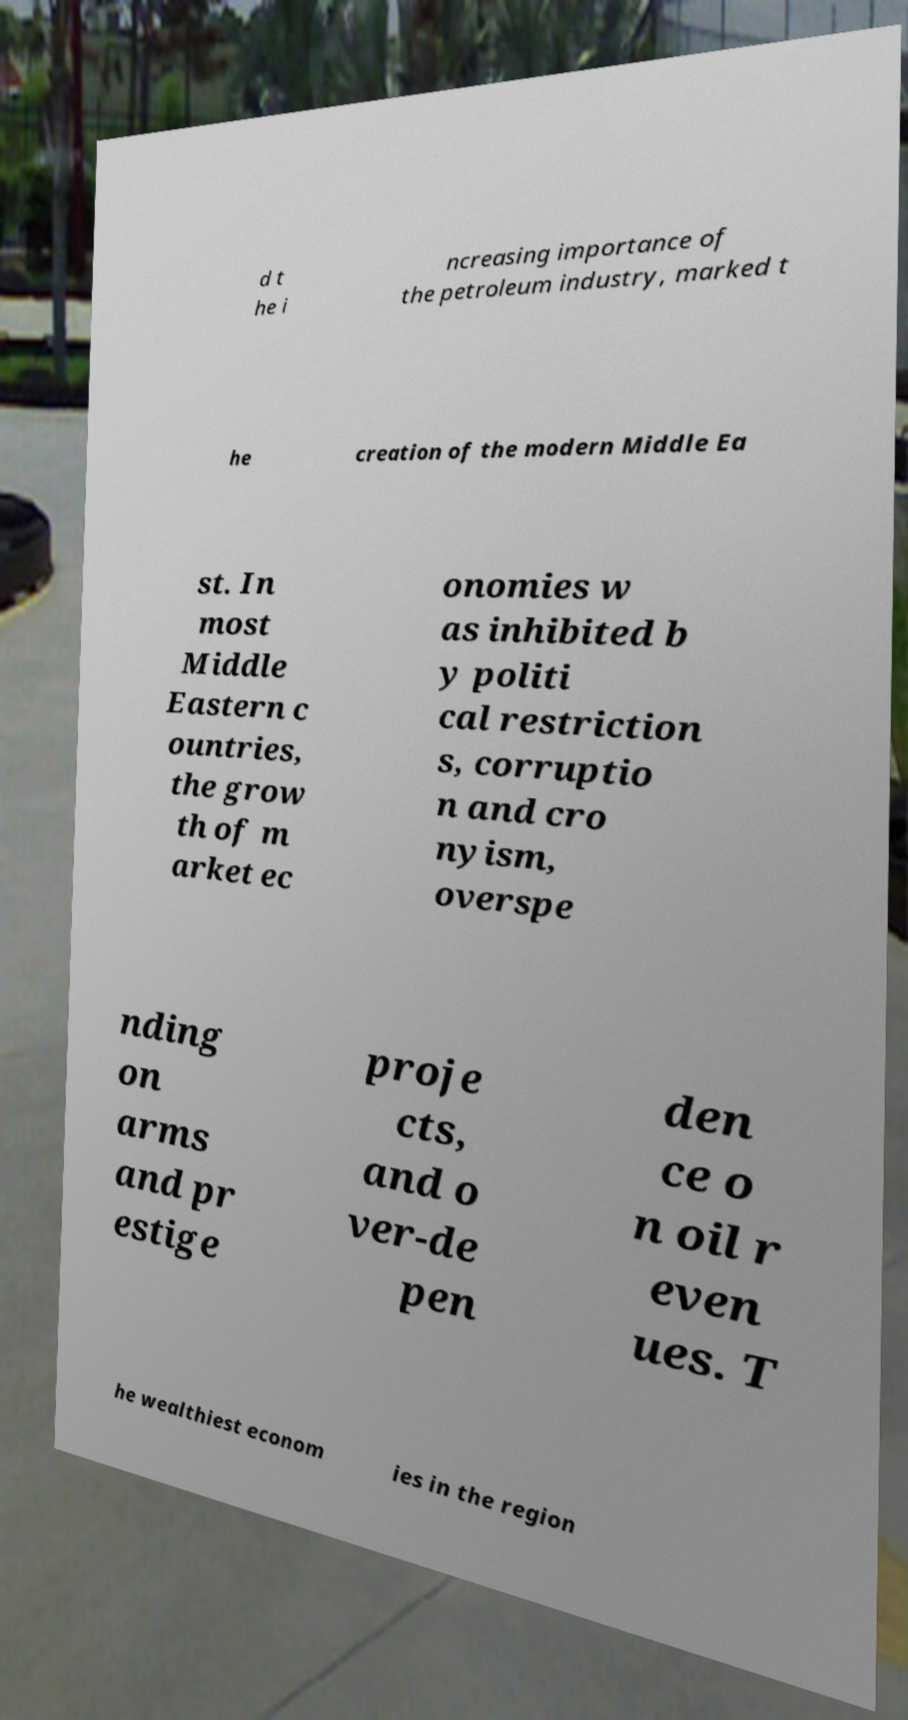There's text embedded in this image that I need extracted. Can you transcribe it verbatim? d t he i ncreasing importance of the petroleum industry, marked t he creation of the modern Middle Ea st. In most Middle Eastern c ountries, the grow th of m arket ec onomies w as inhibited b y politi cal restriction s, corruptio n and cro nyism, overspe nding on arms and pr estige proje cts, and o ver-de pen den ce o n oil r even ues. T he wealthiest econom ies in the region 